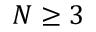Convert formula to latex. <formula><loc_0><loc_0><loc_500><loc_500>N \geq 3</formula> 